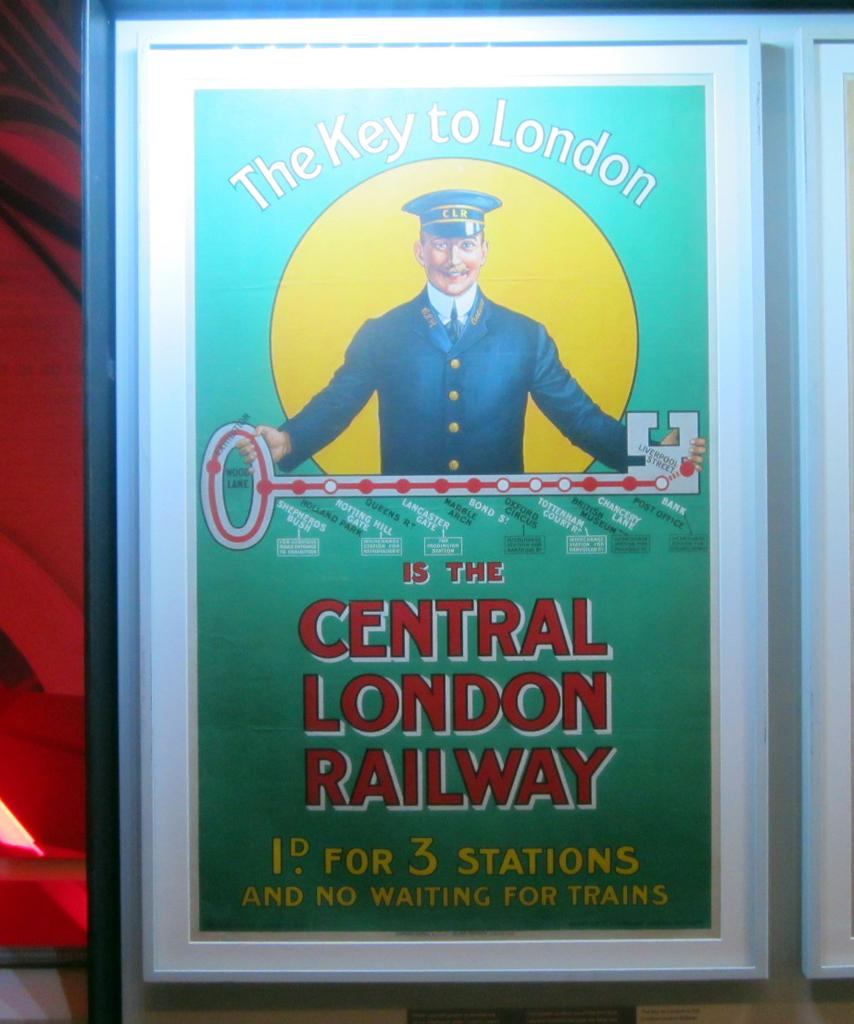Provide a one-sentence caption for the provided image. the key to London is the Central London Railway, according to this advertisement. 